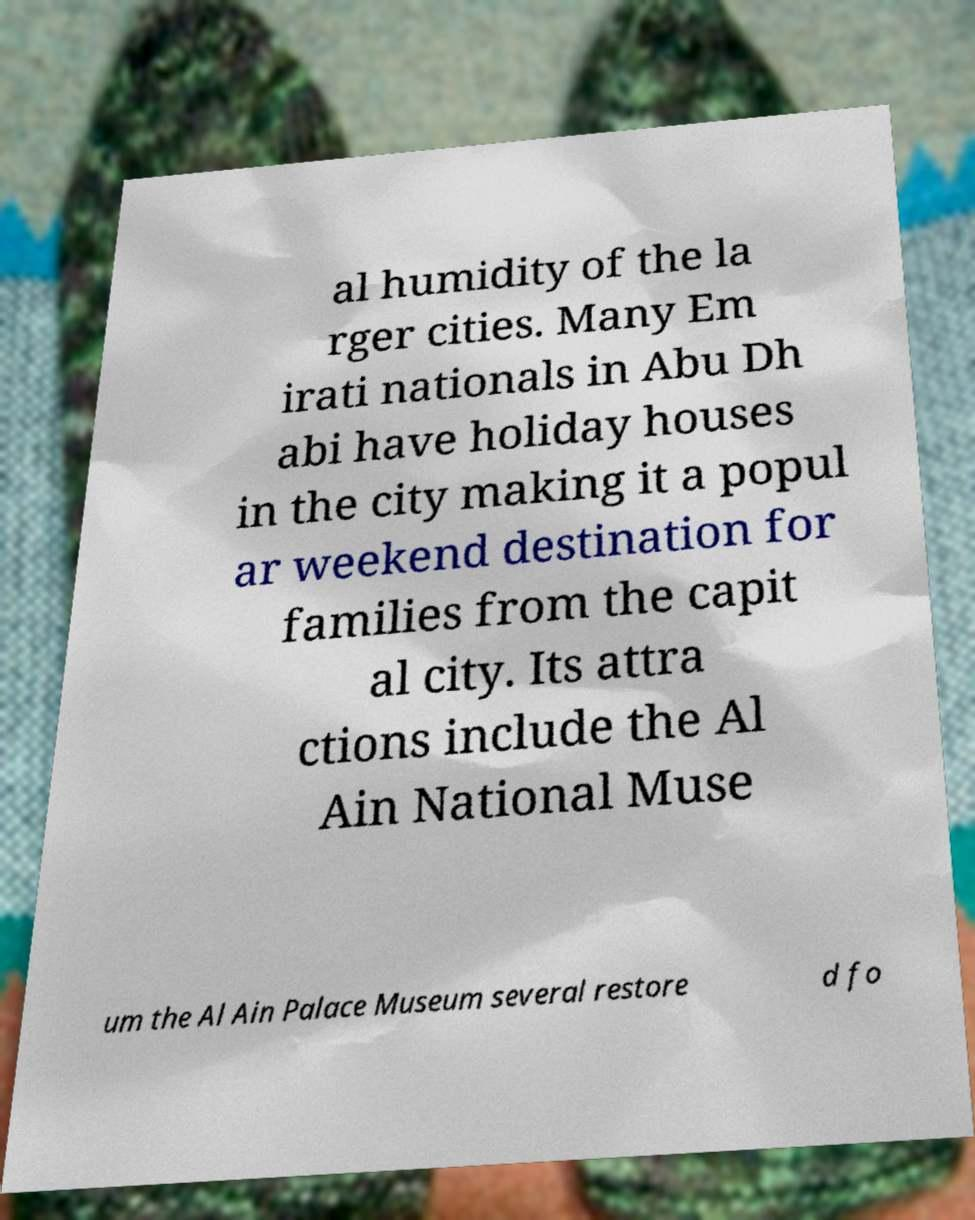Could you extract and type out the text from this image? al humidity of the la rger cities. Many Em irati nationals in Abu Dh abi have holiday houses in the city making it a popul ar weekend destination for families from the capit al city. Its attra ctions include the Al Ain National Muse um the Al Ain Palace Museum several restore d fo 